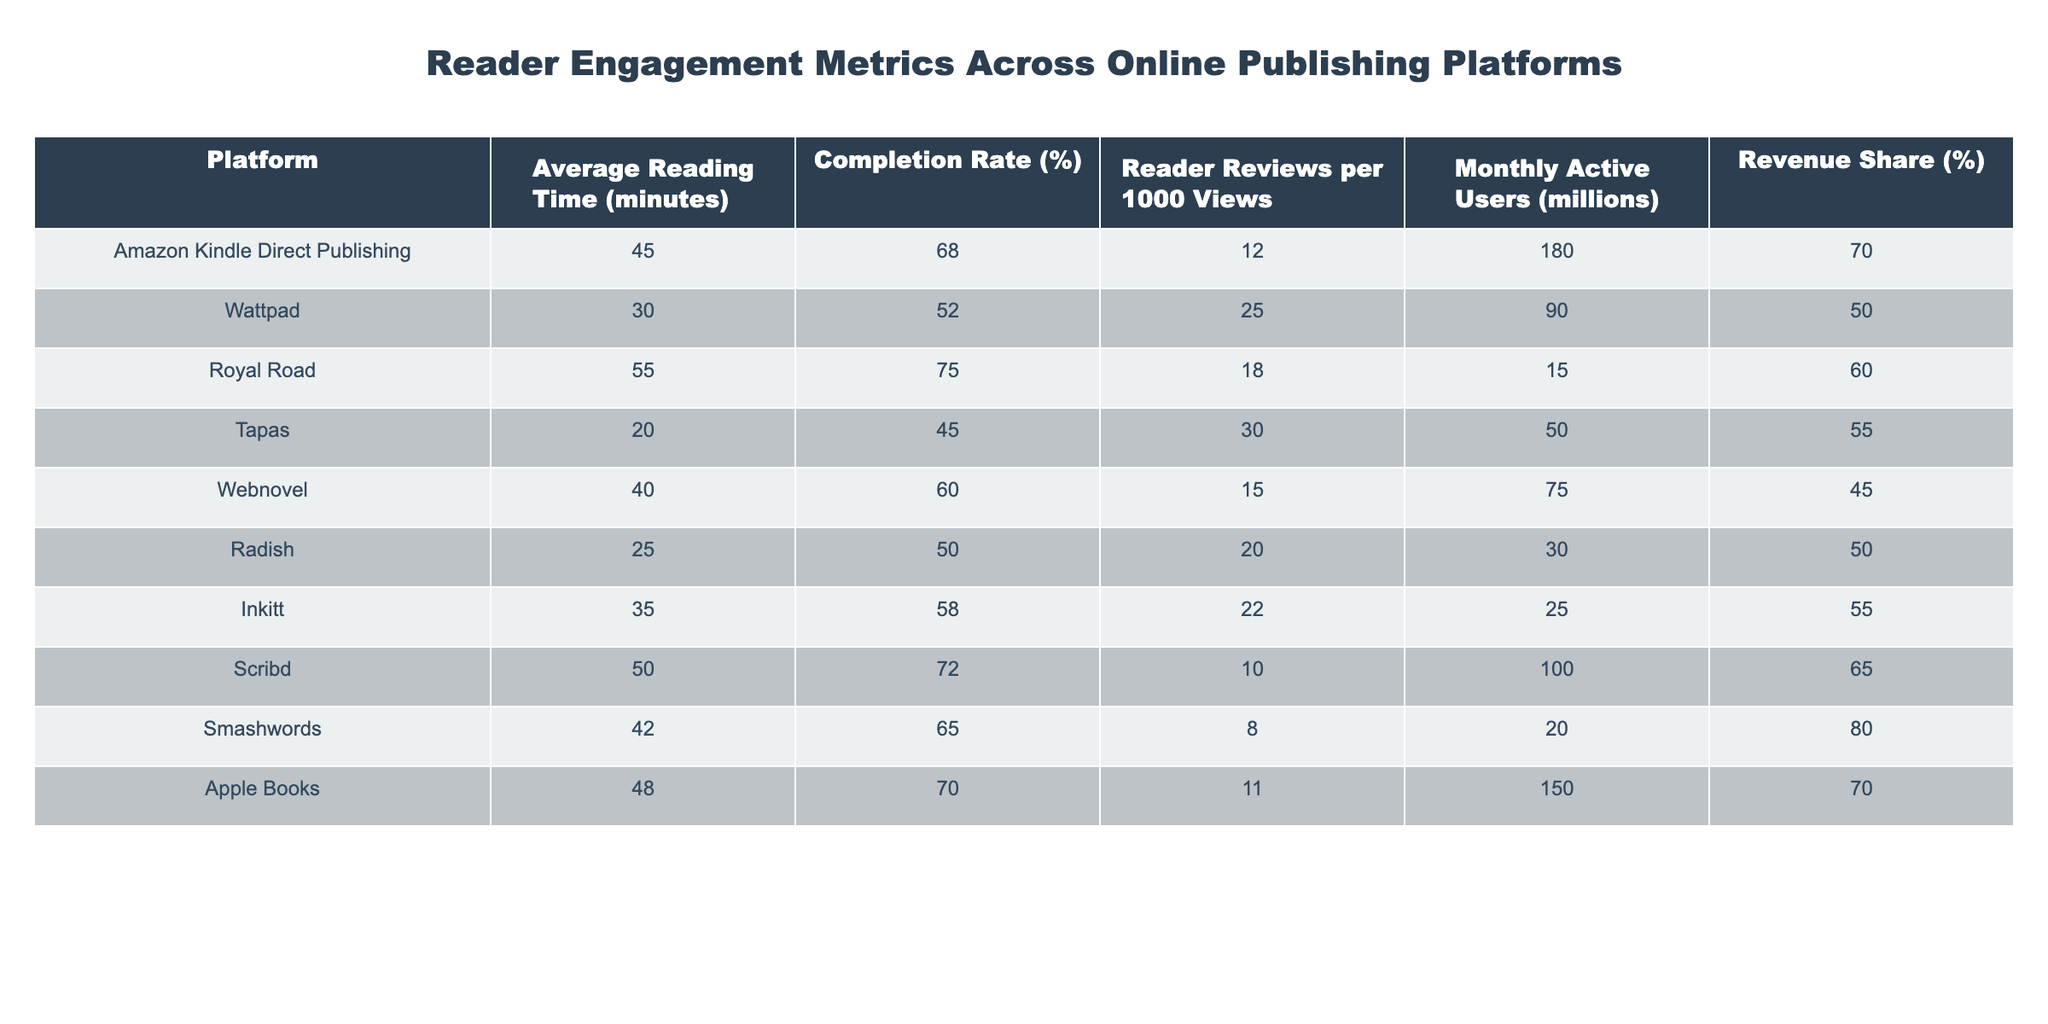What is the platform with the highest average reading time? To find this, we compare the "Average Reading Time (minutes)" column across all platforms. Royal Road has the highest value at 55 minutes.
Answer: Royal Road Which platform has the lowest completion rate? Looking at the "Completion Rate (%)" column, we see Tapas with a completion rate of 45% is the lowest among the listed platforms.
Answer: Tapas What is the revenue share of Amazon Kindle Direct Publishing? We can refer to the "Revenue Share (%)" column and find that Amazon Kindle Direct Publishing has a revenue share of 70%.
Answer: 70% What are the average reading times of platforms whose revenue share is greater than 70%? We identify platforms with revenue shares greater than 70%, which are Amazon Kindle Direct Publishing (70%) and Smashwords (80%). Their average reading time is (45 + 42) / 2 = 43.5 minutes.
Answer: 43.5 minutes Is the completion rate of Webnovel greater than that of Radish? We check the "Completion Rate (%)" for both platforms. Webnovel has 60% and Radish has 50%. Thus, Webnovel’s completion rate is greater than Radish’s.
Answer: Yes Which platform has the highest number of reader reviews per 1000 views? By examining the "Reader Reviews per 1000 Views" column, we see Tapas has the highest at 30 reviews per 1000 views.
Answer: Tapas What is the average completion rate of all platforms listed in the table? We calculate the average of the "Completion Rate (%)" values: (68 + 52 + 75 + 45 + 60 + 50 + 58 + 72 + 65 + 70) / 10 = 61.5%.
Answer: 61.5% Which platform has more than 50 million monthly active users and what is its average reading time? Platforms with more than 50 million monthly active users include Amazon Kindle Direct Publishing (180 million) and Scribd (100 million). Their average reading time is (45 + 50) / 2 = 47.5 minutes.
Answer: 47.5 minutes How many platforms have a completion rate below 60%? By reviewing the "Completion Rate (%)", the platforms with rates below 60% are Wattpad (52%), Tapas (45%), and Radish (50%), totaling three platforms.
Answer: 3 Is it true that Apple Books has a higher average reading time than Inkitt? Comparing their average reading times, Apple Books has 48 minutes and Inkitt has 35 minutes, thus Apple Books does indeed have a higher average reading time than Inkitt.
Answer: Yes 